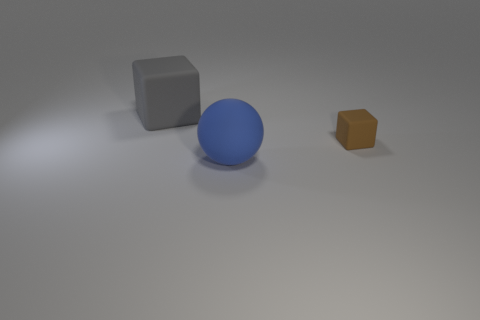How many things are either brown cubes or large objects in front of the small brown rubber object?
Your answer should be compact. 2. How many other objects are the same shape as the large blue thing?
Offer a terse response. 0. How many things are big gray metallic blocks or big matte things?
Keep it short and to the point. 2. There is another rubber object that is the same shape as the small brown matte object; what is its size?
Ensure brevity in your answer.  Large. What is the size of the brown block?
Provide a short and direct response. Small. Are there more gray blocks that are behind the tiny brown cube than cyan shiny cylinders?
Your answer should be very brief. Yes. What material is the large sphere that is in front of the rubber object that is left of the blue rubber sphere in front of the small brown block?
Your answer should be compact. Rubber. Are there more tiny purple matte spheres than big blue spheres?
Offer a terse response. No. What size is the blue sphere that is the same material as the large gray object?
Your answer should be compact. Large. What material is the large blue object?
Make the answer very short. Rubber. 